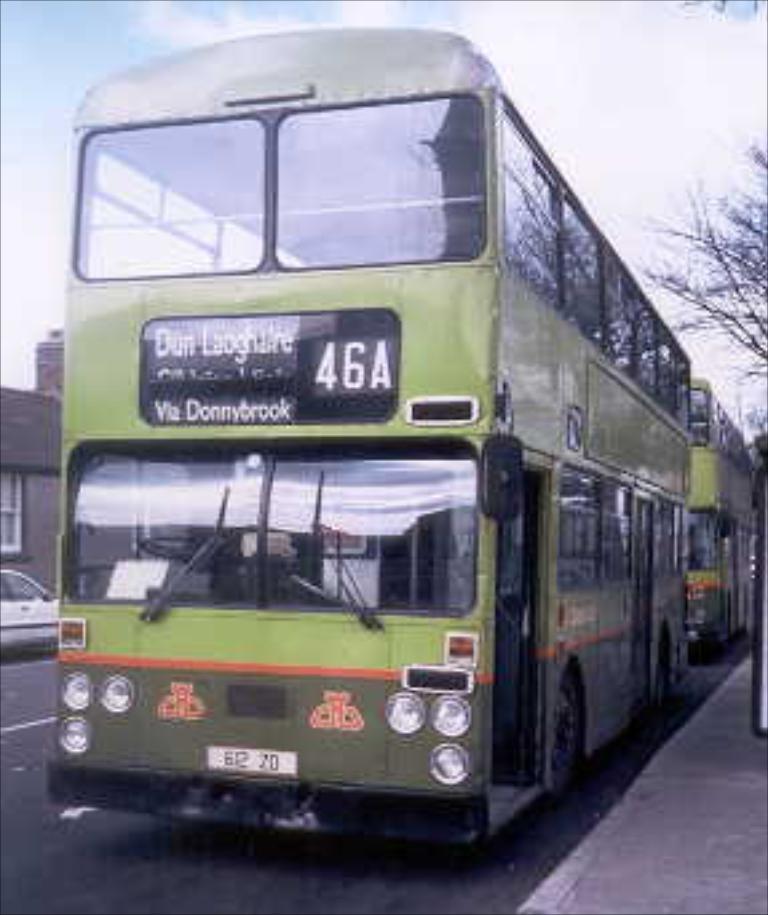Can you describe this image briefly? In this picture, we see a green color double decker bus moving on the road. Beside that, we see a footpath. On the right side, we see a tree. On the left side, we see a white car is moving on the road. Beside that, there are buildings. At the top of the picture, we see the sky. 